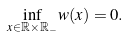<formula> <loc_0><loc_0><loc_500><loc_500>\inf _ { x \in \mathbb { R } \times \mathbb { R } _ { - } } w ( x ) = 0 .</formula> 